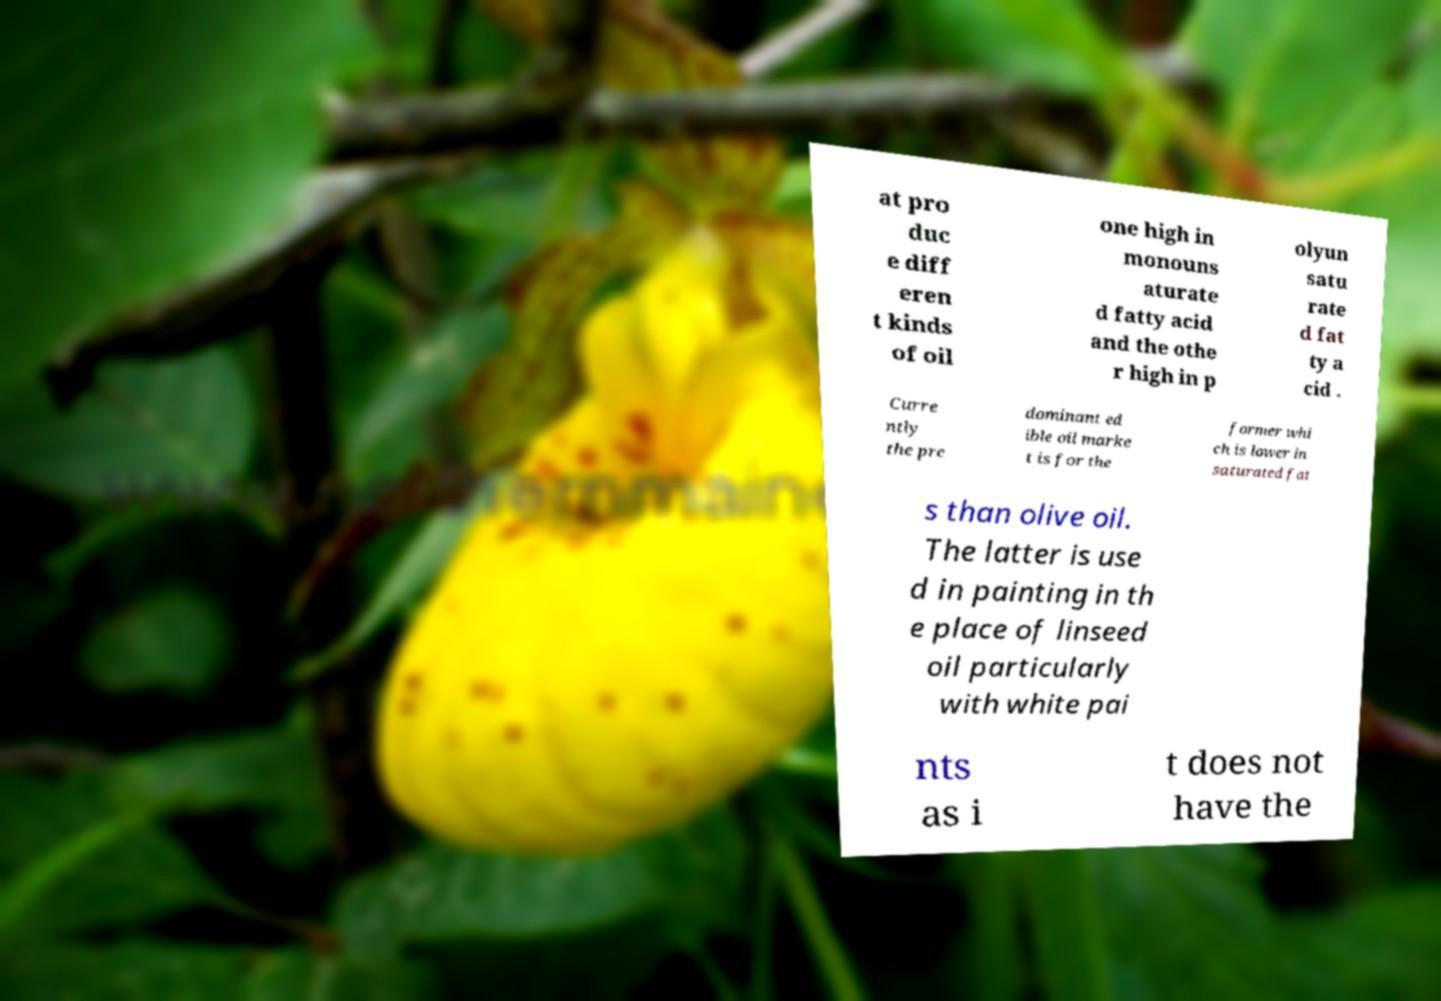Can you read and provide the text displayed in the image?This photo seems to have some interesting text. Can you extract and type it out for me? at pro duc e diff eren t kinds of oil one high in monouns aturate d fatty acid and the othe r high in p olyun satu rate d fat ty a cid . Curre ntly the pre dominant ed ible oil marke t is for the former whi ch is lower in saturated fat s than olive oil. The latter is use d in painting in th e place of linseed oil particularly with white pai nts as i t does not have the 